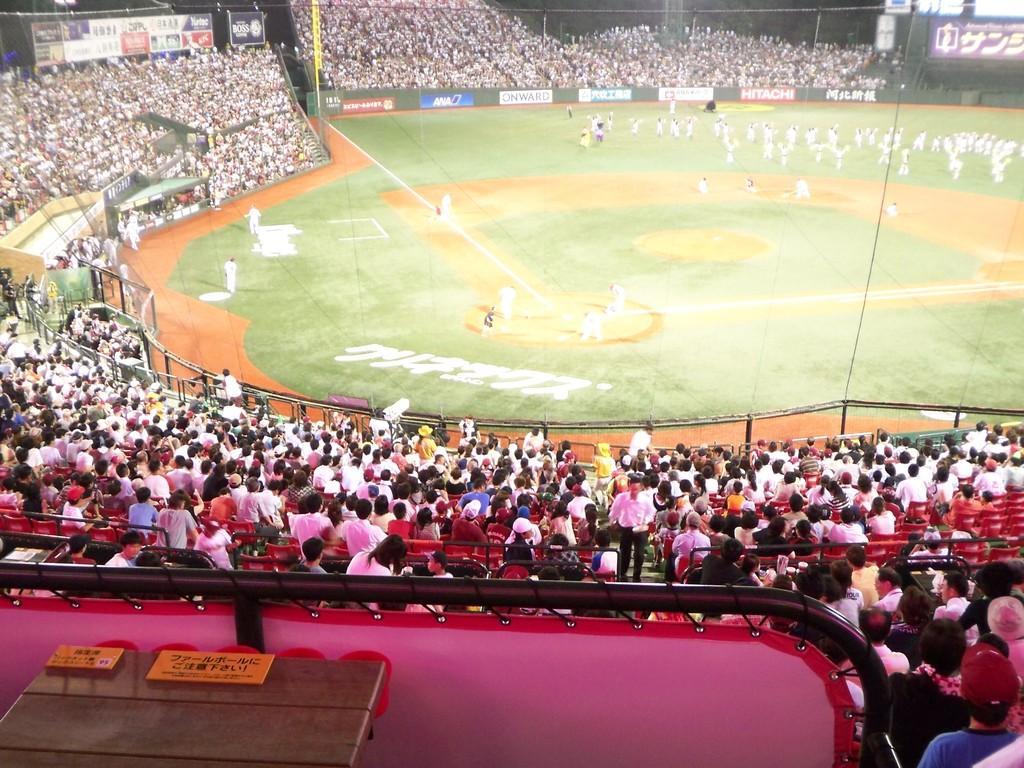Describe this image in one or two sentences. In this image we can see the players in the background. We can also see many people sitting and few are standing. We can also see the stands and also the fence and hoardings. In the bottom left corner we can see the wooden table and also the text on the yellow color boards. 